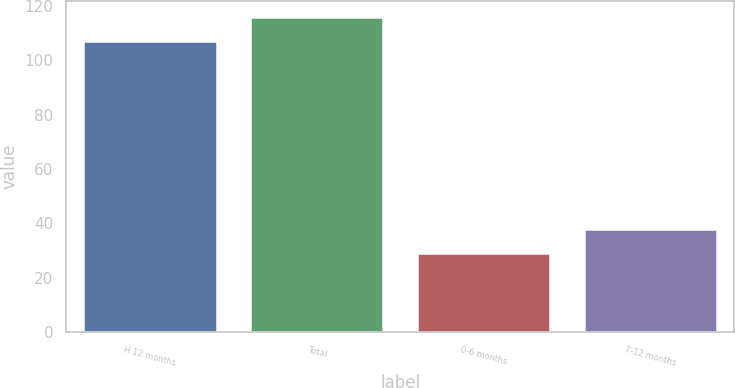<chart> <loc_0><loc_0><loc_500><loc_500><bar_chart><fcel>H 12 months<fcel>Total<fcel>0-6 months<fcel>7-12 months<nl><fcel>107<fcel>116<fcel>29<fcel>38<nl></chart> 